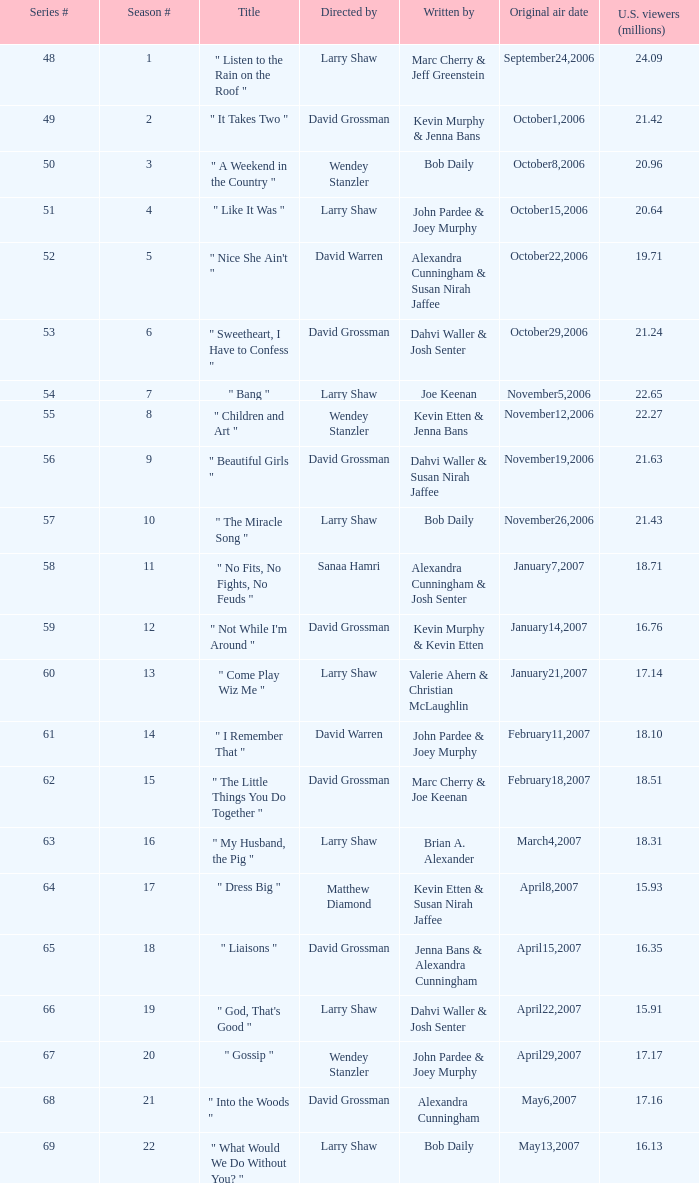What series number garnered 20.64 million viewers? 51.0. 